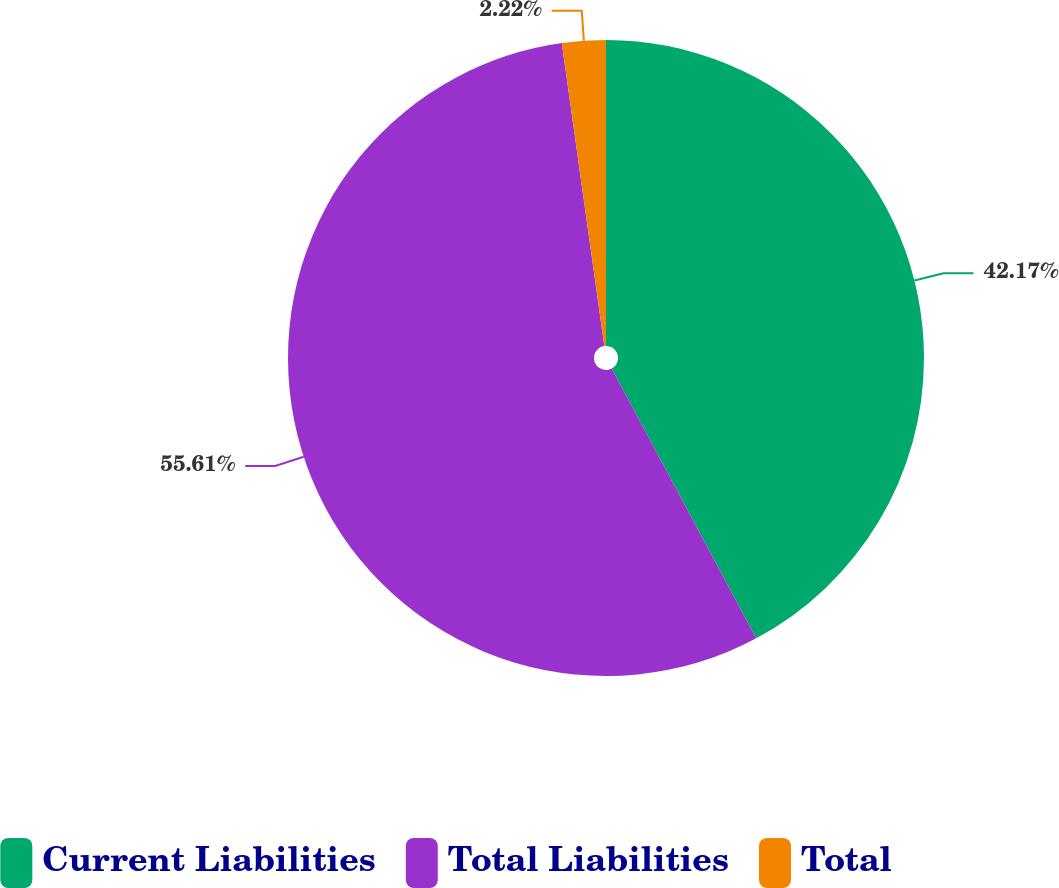Convert chart to OTSL. <chart><loc_0><loc_0><loc_500><loc_500><pie_chart><fcel>Current Liabilities<fcel>Total Liabilities<fcel>Total<nl><fcel>42.17%<fcel>55.61%<fcel>2.22%<nl></chart> 